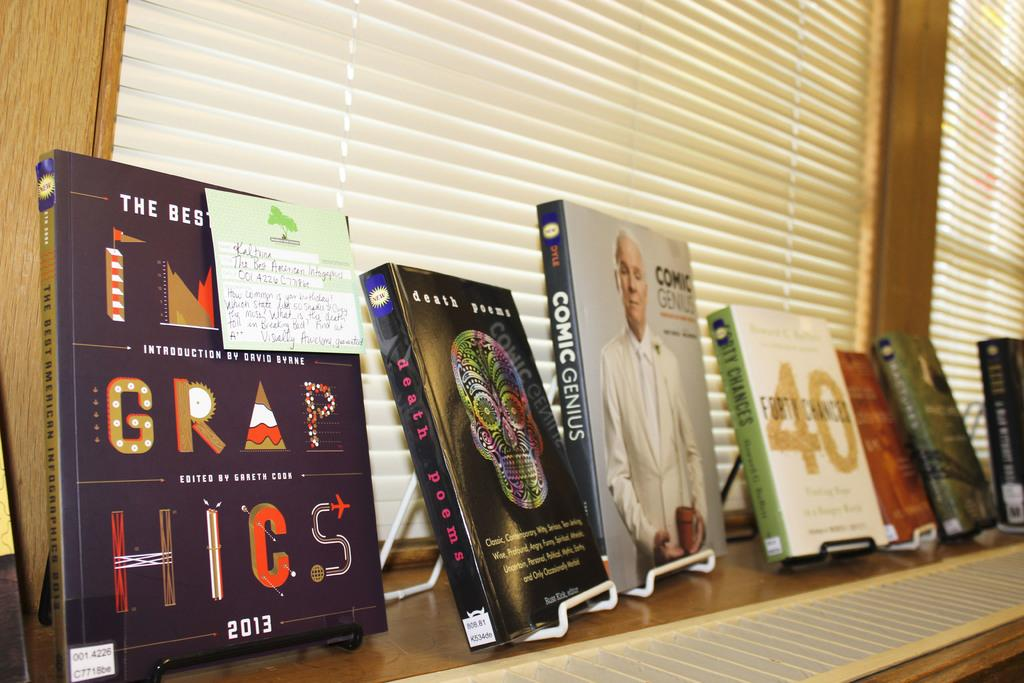What type of window treatment is visible in the image? There are curtains in the image. What objects can be seen on a stand in the image? There are books on a stand in the image. Can you describe the books in the image? The books have writing on them. Is there any representation of a person in the image? Yes, there is an image of a person in the image. Are there any visible signs of a prison in the image? There is no indication of a prison in the image. What type of creature can be seen interacting with the books in the image? There is no creature present in the image; it only features books, a stand, curtains, and an image of a person. 